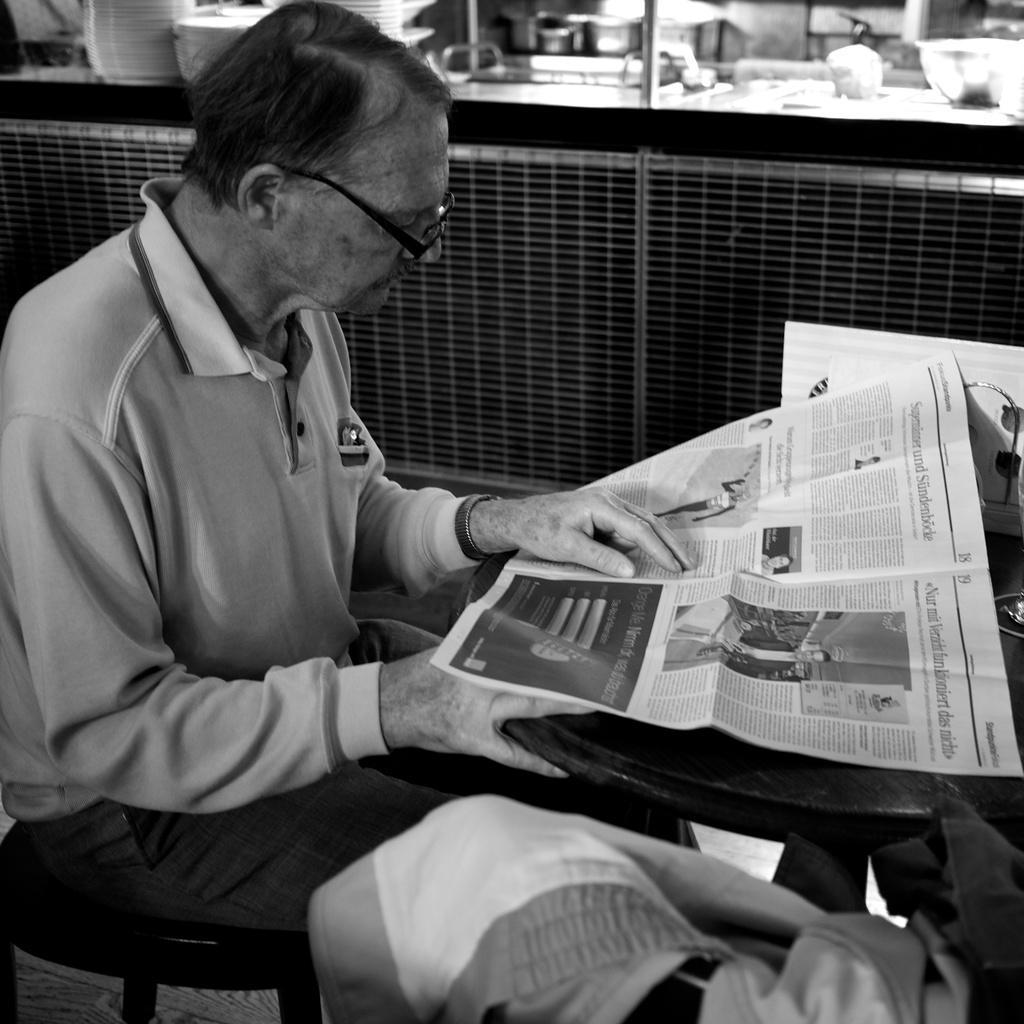Could you give a brief overview of what you see in this image? In this image, we can see an old person is sitting on the chair and keeping his hand on the newspaper. Here there is a table, few objects on it. At the bottom, we can see cloth and floor. Background we can see kitchen platform, few utensils we can see. 